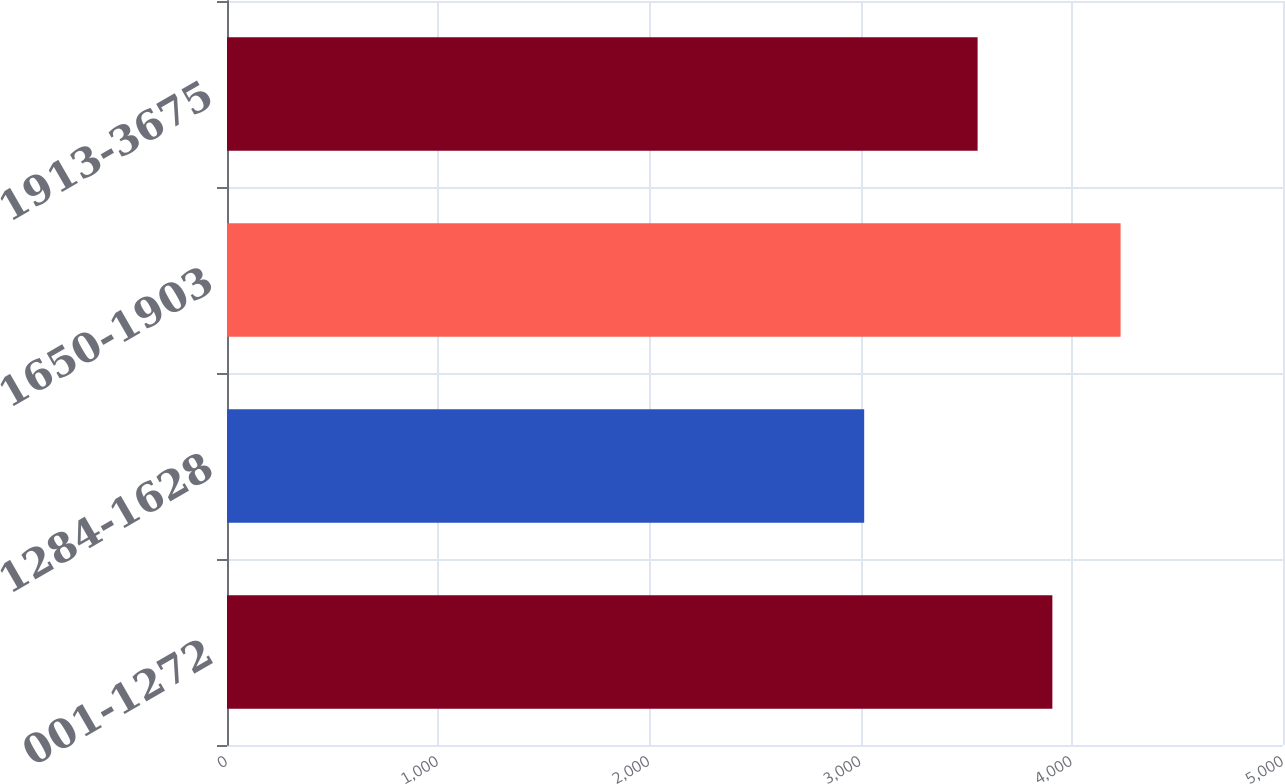<chart> <loc_0><loc_0><loc_500><loc_500><bar_chart><fcel>001-1272<fcel>1284-1628<fcel>1650-1903<fcel>1913-3675<nl><fcel>3908<fcel>3017<fcel>4231<fcel>3554<nl></chart> 